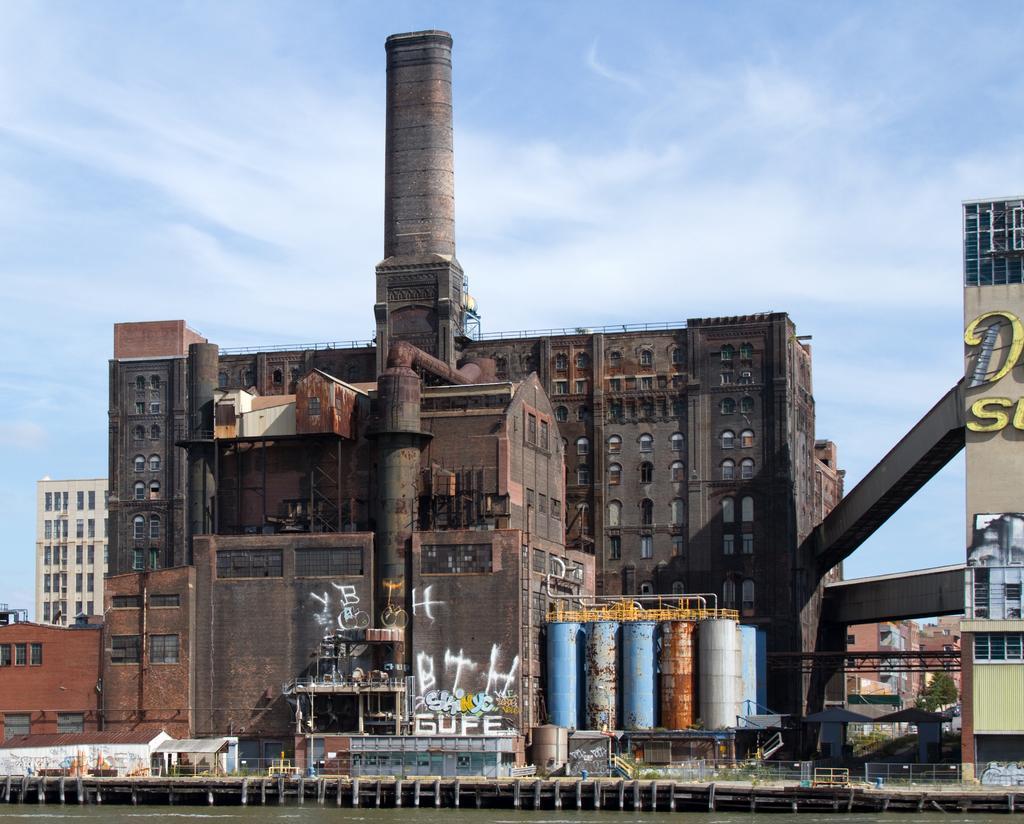Could you give a brief overview of what you see in this image? In this picture we can see a factory. Behind the factory there are buildings and the sky. At the bottom of the image, there are plants, fences and water. On the right side of the image, there is a tree. 